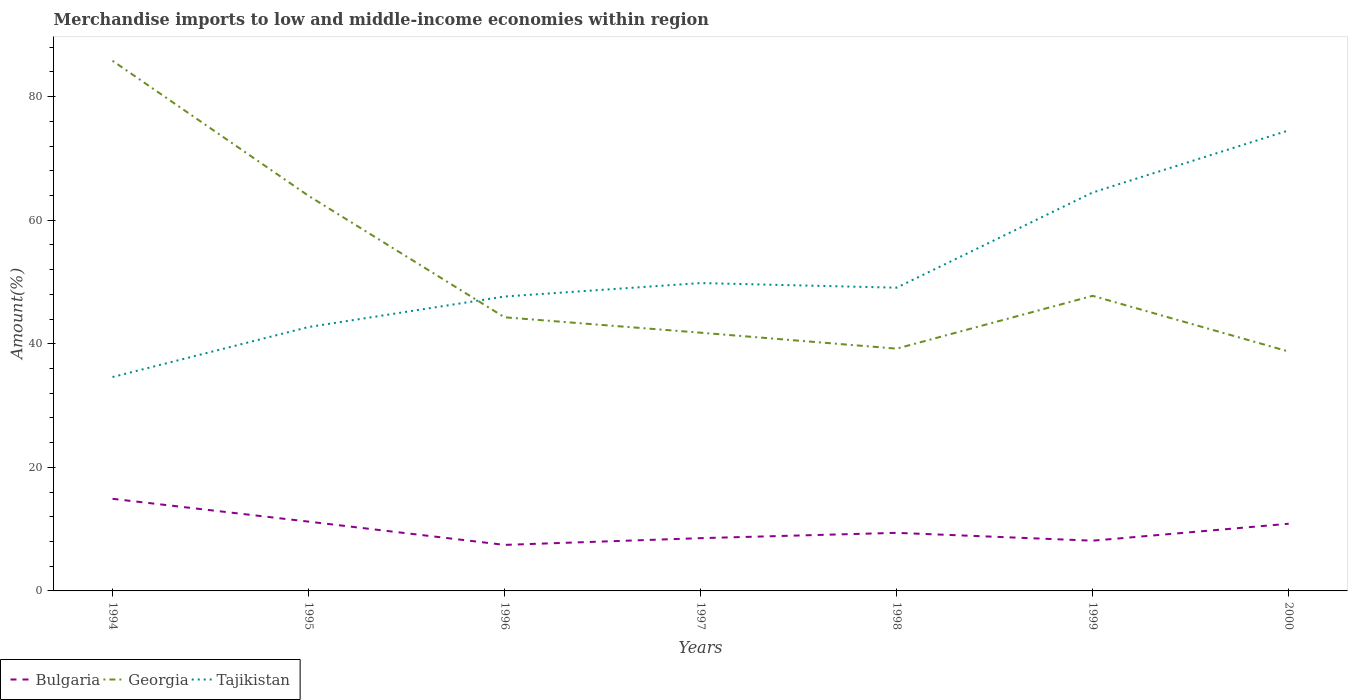How many different coloured lines are there?
Your answer should be compact. 3. Is the number of lines equal to the number of legend labels?
Provide a short and direct response. Yes. Across all years, what is the maximum percentage of amount earned from merchandise imports in Bulgaria?
Keep it short and to the point. 7.45. What is the total percentage of amount earned from merchandise imports in Georgia in the graph?
Provide a succinct answer. 9.01. What is the difference between the highest and the second highest percentage of amount earned from merchandise imports in Tajikistan?
Provide a short and direct response. 39.92. How many years are there in the graph?
Your answer should be very brief. 7. Does the graph contain any zero values?
Provide a short and direct response. No. Does the graph contain grids?
Make the answer very short. No. Where does the legend appear in the graph?
Offer a very short reply. Bottom left. How are the legend labels stacked?
Your answer should be very brief. Horizontal. What is the title of the graph?
Your response must be concise. Merchandise imports to low and middle-income economies within region. What is the label or title of the X-axis?
Give a very brief answer. Years. What is the label or title of the Y-axis?
Ensure brevity in your answer.  Amount(%). What is the Amount(%) of Bulgaria in 1994?
Your answer should be compact. 14.91. What is the Amount(%) of Georgia in 1994?
Ensure brevity in your answer.  85.81. What is the Amount(%) in Tajikistan in 1994?
Make the answer very short. 34.62. What is the Amount(%) in Bulgaria in 1995?
Make the answer very short. 11.22. What is the Amount(%) of Georgia in 1995?
Keep it short and to the point. 63.95. What is the Amount(%) in Tajikistan in 1995?
Provide a succinct answer. 42.71. What is the Amount(%) in Bulgaria in 1996?
Make the answer very short. 7.45. What is the Amount(%) of Georgia in 1996?
Provide a succinct answer. 44.29. What is the Amount(%) of Tajikistan in 1996?
Keep it short and to the point. 47.65. What is the Amount(%) in Bulgaria in 1997?
Your answer should be compact. 8.54. What is the Amount(%) of Georgia in 1997?
Ensure brevity in your answer.  41.8. What is the Amount(%) in Tajikistan in 1997?
Your answer should be compact. 49.83. What is the Amount(%) in Bulgaria in 1998?
Provide a succinct answer. 9.4. What is the Amount(%) of Georgia in 1998?
Ensure brevity in your answer.  39.22. What is the Amount(%) in Tajikistan in 1998?
Ensure brevity in your answer.  49.08. What is the Amount(%) in Bulgaria in 1999?
Offer a very short reply. 8.13. What is the Amount(%) in Georgia in 1999?
Your answer should be compact. 47.76. What is the Amount(%) in Tajikistan in 1999?
Provide a succinct answer. 64.49. What is the Amount(%) of Bulgaria in 2000?
Your answer should be very brief. 10.87. What is the Amount(%) in Georgia in 2000?
Offer a very short reply. 38.75. What is the Amount(%) of Tajikistan in 2000?
Your answer should be compact. 74.54. Across all years, what is the maximum Amount(%) of Bulgaria?
Your answer should be very brief. 14.91. Across all years, what is the maximum Amount(%) of Georgia?
Provide a succinct answer. 85.81. Across all years, what is the maximum Amount(%) of Tajikistan?
Keep it short and to the point. 74.54. Across all years, what is the minimum Amount(%) in Bulgaria?
Offer a terse response. 7.45. Across all years, what is the minimum Amount(%) in Georgia?
Your response must be concise. 38.75. Across all years, what is the minimum Amount(%) in Tajikistan?
Give a very brief answer. 34.62. What is the total Amount(%) of Bulgaria in the graph?
Your answer should be very brief. 70.52. What is the total Amount(%) of Georgia in the graph?
Ensure brevity in your answer.  361.57. What is the total Amount(%) in Tajikistan in the graph?
Offer a terse response. 362.93. What is the difference between the Amount(%) in Bulgaria in 1994 and that in 1995?
Keep it short and to the point. 3.69. What is the difference between the Amount(%) in Georgia in 1994 and that in 1995?
Your answer should be very brief. 21.86. What is the difference between the Amount(%) of Tajikistan in 1994 and that in 1995?
Your answer should be very brief. -8.09. What is the difference between the Amount(%) of Bulgaria in 1994 and that in 1996?
Give a very brief answer. 7.46. What is the difference between the Amount(%) of Georgia in 1994 and that in 1996?
Ensure brevity in your answer.  41.52. What is the difference between the Amount(%) of Tajikistan in 1994 and that in 1996?
Give a very brief answer. -13.03. What is the difference between the Amount(%) in Bulgaria in 1994 and that in 1997?
Give a very brief answer. 6.37. What is the difference between the Amount(%) in Georgia in 1994 and that in 1997?
Your response must be concise. 44.01. What is the difference between the Amount(%) of Tajikistan in 1994 and that in 1997?
Offer a very short reply. -15.21. What is the difference between the Amount(%) in Bulgaria in 1994 and that in 1998?
Your answer should be very brief. 5.51. What is the difference between the Amount(%) of Georgia in 1994 and that in 1998?
Your answer should be very brief. 46.59. What is the difference between the Amount(%) in Tajikistan in 1994 and that in 1998?
Offer a terse response. -14.46. What is the difference between the Amount(%) in Bulgaria in 1994 and that in 1999?
Offer a very short reply. 6.78. What is the difference between the Amount(%) in Georgia in 1994 and that in 1999?
Provide a succinct answer. 38.05. What is the difference between the Amount(%) of Tajikistan in 1994 and that in 1999?
Ensure brevity in your answer.  -29.87. What is the difference between the Amount(%) in Bulgaria in 1994 and that in 2000?
Your answer should be very brief. 4.04. What is the difference between the Amount(%) in Georgia in 1994 and that in 2000?
Your answer should be compact. 47.06. What is the difference between the Amount(%) in Tajikistan in 1994 and that in 2000?
Give a very brief answer. -39.92. What is the difference between the Amount(%) in Bulgaria in 1995 and that in 1996?
Keep it short and to the point. 3.76. What is the difference between the Amount(%) of Georgia in 1995 and that in 1996?
Keep it short and to the point. 19.66. What is the difference between the Amount(%) in Tajikistan in 1995 and that in 1996?
Make the answer very short. -4.94. What is the difference between the Amount(%) of Bulgaria in 1995 and that in 1997?
Offer a very short reply. 2.68. What is the difference between the Amount(%) in Georgia in 1995 and that in 1997?
Provide a short and direct response. 22.15. What is the difference between the Amount(%) of Tajikistan in 1995 and that in 1997?
Give a very brief answer. -7.12. What is the difference between the Amount(%) in Bulgaria in 1995 and that in 1998?
Provide a succinct answer. 1.82. What is the difference between the Amount(%) in Georgia in 1995 and that in 1998?
Make the answer very short. 24.73. What is the difference between the Amount(%) of Tajikistan in 1995 and that in 1998?
Offer a terse response. -6.37. What is the difference between the Amount(%) of Bulgaria in 1995 and that in 1999?
Offer a very short reply. 3.08. What is the difference between the Amount(%) of Georgia in 1995 and that in 1999?
Offer a very short reply. 16.19. What is the difference between the Amount(%) in Tajikistan in 1995 and that in 1999?
Offer a very short reply. -21.78. What is the difference between the Amount(%) in Bulgaria in 1995 and that in 2000?
Your response must be concise. 0.34. What is the difference between the Amount(%) in Georgia in 1995 and that in 2000?
Offer a very short reply. 25.2. What is the difference between the Amount(%) in Tajikistan in 1995 and that in 2000?
Ensure brevity in your answer.  -31.83. What is the difference between the Amount(%) of Bulgaria in 1996 and that in 1997?
Provide a short and direct response. -1.09. What is the difference between the Amount(%) in Georgia in 1996 and that in 1997?
Ensure brevity in your answer.  2.49. What is the difference between the Amount(%) of Tajikistan in 1996 and that in 1997?
Your response must be concise. -2.18. What is the difference between the Amount(%) in Bulgaria in 1996 and that in 1998?
Your answer should be very brief. -1.95. What is the difference between the Amount(%) in Georgia in 1996 and that in 1998?
Provide a short and direct response. 5.07. What is the difference between the Amount(%) in Tajikistan in 1996 and that in 1998?
Offer a terse response. -1.43. What is the difference between the Amount(%) of Bulgaria in 1996 and that in 1999?
Offer a very short reply. -0.68. What is the difference between the Amount(%) of Georgia in 1996 and that in 1999?
Your answer should be very brief. -3.47. What is the difference between the Amount(%) in Tajikistan in 1996 and that in 1999?
Your answer should be very brief. -16.84. What is the difference between the Amount(%) of Bulgaria in 1996 and that in 2000?
Keep it short and to the point. -3.42. What is the difference between the Amount(%) of Georgia in 1996 and that in 2000?
Ensure brevity in your answer.  5.54. What is the difference between the Amount(%) in Tajikistan in 1996 and that in 2000?
Provide a succinct answer. -26.89. What is the difference between the Amount(%) in Bulgaria in 1997 and that in 1998?
Make the answer very short. -0.86. What is the difference between the Amount(%) of Georgia in 1997 and that in 1998?
Your response must be concise. 2.58. What is the difference between the Amount(%) of Tajikistan in 1997 and that in 1998?
Offer a terse response. 0.75. What is the difference between the Amount(%) of Bulgaria in 1997 and that in 1999?
Ensure brevity in your answer.  0.41. What is the difference between the Amount(%) of Georgia in 1997 and that in 1999?
Keep it short and to the point. -5.96. What is the difference between the Amount(%) of Tajikistan in 1997 and that in 1999?
Keep it short and to the point. -14.66. What is the difference between the Amount(%) in Bulgaria in 1997 and that in 2000?
Your response must be concise. -2.33. What is the difference between the Amount(%) of Georgia in 1997 and that in 2000?
Give a very brief answer. 3.05. What is the difference between the Amount(%) in Tajikistan in 1997 and that in 2000?
Provide a succinct answer. -24.71. What is the difference between the Amount(%) in Bulgaria in 1998 and that in 1999?
Keep it short and to the point. 1.27. What is the difference between the Amount(%) in Georgia in 1998 and that in 1999?
Your answer should be compact. -8.55. What is the difference between the Amount(%) of Tajikistan in 1998 and that in 1999?
Offer a terse response. -15.41. What is the difference between the Amount(%) of Bulgaria in 1998 and that in 2000?
Provide a succinct answer. -1.47. What is the difference between the Amount(%) in Georgia in 1998 and that in 2000?
Your answer should be very brief. 0.47. What is the difference between the Amount(%) in Tajikistan in 1998 and that in 2000?
Make the answer very short. -25.46. What is the difference between the Amount(%) of Bulgaria in 1999 and that in 2000?
Keep it short and to the point. -2.74. What is the difference between the Amount(%) of Georgia in 1999 and that in 2000?
Provide a succinct answer. 9.01. What is the difference between the Amount(%) of Tajikistan in 1999 and that in 2000?
Give a very brief answer. -10.05. What is the difference between the Amount(%) in Bulgaria in 1994 and the Amount(%) in Georgia in 1995?
Your answer should be compact. -49.04. What is the difference between the Amount(%) of Bulgaria in 1994 and the Amount(%) of Tajikistan in 1995?
Keep it short and to the point. -27.8. What is the difference between the Amount(%) in Georgia in 1994 and the Amount(%) in Tajikistan in 1995?
Give a very brief answer. 43.09. What is the difference between the Amount(%) of Bulgaria in 1994 and the Amount(%) of Georgia in 1996?
Ensure brevity in your answer.  -29.38. What is the difference between the Amount(%) in Bulgaria in 1994 and the Amount(%) in Tajikistan in 1996?
Your answer should be very brief. -32.74. What is the difference between the Amount(%) in Georgia in 1994 and the Amount(%) in Tajikistan in 1996?
Offer a terse response. 38.16. What is the difference between the Amount(%) in Bulgaria in 1994 and the Amount(%) in Georgia in 1997?
Make the answer very short. -26.89. What is the difference between the Amount(%) in Bulgaria in 1994 and the Amount(%) in Tajikistan in 1997?
Provide a short and direct response. -34.92. What is the difference between the Amount(%) in Georgia in 1994 and the Amount(%) in Tajikistan in 1997?
Your answer should be very brief. 35.98. What is the difference between the Amount(%) of Bulgaria in 1994 and the Amount(%) of Georgia in 1998?
Offer a very short reply. -24.31. What is the difference between the Amount(%) in Bulgaria in 1994 and the Amount(%) in Tajikistan in 1998?
Your response must be concise. -34.17. What is the difference between the Amount(%) of Georgia in 1994 and the Amount(%) of Tajikistan in 1998?
Your response must be concise. 36.73. What is the difference between the Amount(%) in Bulgaria in 1994 and the Amount(%) in Georgia in 1999?
Offer a terse response. -32.85. What is the difference between the Amount(%) in Bulgaria in 1994 and the Amount(%) in Tajikistan in 1999?
Give a very brief answer. -49.58. What is the difference between the Amount(%) of Georgia in 1994 and the Amount(%) of Tajikistan in 1999?
Offer a terse response. 21.32. What is the difference between the Amount(%) of Bulgaria in 1994 and the Amount(%) of Georgia in 2000?
Provide a succinct answer. -23.84. What is the difference between the Amount(%) of Bulgaria in 1994 and the Amount(%) of Tajikistan in 2000?
Your answer should be compact. -59.63. What is the difference between the Amount(%) of Georgia in 1994 and the Amount(%) of Tajikistan in 2000?
Your answer should be very brief. 11.27. What is the difference between the Amount(%) of Bulgaria in 1995 and the Amount(%) of Georgia in 1996?
Your response must be concise. -33.07. What is the difference between the Amount(%) in Bulgaria in 1995 and the Amount(%) in Tajikistan in 1996?
Provide a short and direct response. -36.44. What is the difference between the Amount(%) in Georgia in 1995 and the Amount(%) in Tajikistan in 1996?
Provide a short and direct response. 16.3. What is the difference between the Amount(%) of Bulgaria in 1995 and the Amount(%) of Georgia in 1997?
Provide a succinct answer. -30.58. What is the difference between the Amount(%) of Bulgaria in 1995 and the Amount(%) of Tajikistan in 1997?
Make the answer very short. -38.61. What is the difference between the Amount(%) of Georgia in 1995 and the Amount(%) of Tajikistan in 1997?
Give a very brief answer. 14.12. What is the difference between the Amount(%) in Bulgaria in 1995 and the Amount(%) in Georgia in 1998?
Give a very brief answer. -28. What is the difference between the Amount(%) in Bulgaria in 1995 and the Amount(%) in Tajikistan in 1998?
Your answer should be very brief. -37.87. What is the difference between the Amount(%) in Georgia in 1995 and the Amount(%) in Tajikistan in 1998?
Your response must be concise. 14.87. What is the difference between the Amount(%) in Bulgaria in 1995 and the Amount(%) in Georgia in 1999?
Provide a short and direct response. -36.55. What is the difference between the Amount(%) in Bulgaria in 1995 and the Amount(%) in Tajikistan in 1999?
Ensure brevity in your answer.  -53.27. What is the difference between the Amount(%) of Georgia in 1995 and the Amount(%) of Tajikistan in 1999?
Your response must be concise. -0.54. What is the difference between the Amount(%) in Bulgaria in 1995 and the Amount(%) in Georgia in 2000?
Offer a very short reply. -27.53. What is the difference between the Amount(%) in Bulgaria in 1995 and the Amount(%) in Tajikistan in 2000?
Make the answer very short. -63.33. What is the difference between the Amount(%) in Georgia in 1995 and the Amount(%) in Tajikistan in 2000?
Your answer should be very brief. -10.59. What is the difference between the Amount(%) in Bulgaria in 1996 and the Amount(%) in Georgia in 1997?
Provide a short and direct response. -34.35. What is the difference between the Amount(%) in Bulgaria in 1996 and the Amount(%) in Tajikistan in 1997?
Your answer should be compact. -42.38. What is the difference between the Amount(%) of Georgia in 1996 and the Amount(%) of Tajikistan in 1997?
Ensure brevity in your answer.  -5.54. What is the difference between the Amount(%) of Bulgaria in 1996 and the Amount(%) of Georgia in 1998?
Provide a short and direct response. -31.77. What is the difference between the Amount(%) in Bulgaria in 1996 and the Amount(%) in Tajikistan in 1998?
Offer a terse response. -41.63. What is the difference between the Amount(%) of Georgia in 1996 and the Amount(%) of Tajikistan in 1998?
Your response must be concise. -4.79. What is the difference between the Amount(%) of Bulgaria in 1996 and the Amount(%) of Georgia in 1999?
Ensure brevity in your answer.  -40.31. What is the difference between the Amount(%) in Bulgaria in 1996 and the Amount(%) in Tajikistan in 1999?
Give a very brief answer. -57.04. What is the difference between the Amount(%) in Georgia in 1996 and the Amount(%) in Tajikistan in 1999?
Your answer should be very brief. -20.2. What is the difference between the Amount(%) in Bulgaria in 1996 and the Amount(%) in Georgia in 2000?
Offer a very short reply. -31.3. What is the difference between the Amount(%) of Bulgaria in 1996 and the Amount(%) of Tajikistan in 2000?
Ensure brevity in your answer.  -67.09. What is the difference between the Amount(%) in Georgia in 1996 and the Amount(%) in Tajikistan in 2000?
Your answer should be compact. -30.25. What is the difference between the Amount(%) of Bulgaria in 1997 and the Amount(%) of Georgia in 1998?
Offer a terse response. -30.68. What is the difference between the Amount(%) of Bulgaria in 1997 and the Amount(%) of Tajikistan in 1998?
Your response must be concise. -40.54. What is the difference between the Amount(%) of Georgia in 1997 and the Amount(%) of Tajikistan in 1998?
Ensure brevity in your answer.  -7.29. What is the difference between the Amount(%) in Bulgaria in 1997 and the Amount(%) in Georgia in 1999?
Your response must be concise. -39.22. What is the difference between the Amount(%) in Bulgaria in 1997 and the Amount(%) in Tajikistan in 1999?
Your response must be concise. -55.95. What is the difference between the Amount(%) of Georgia in 1997 and the Amount(%) of Tajikistan in 1999?
Provide a short and direct response. -22.69. What is the difference between the Amount(%) in Bulgaria in 1997 and the Amount(%) in Georgia in 2000?
Provide a short and direct response. -30.21. What is the difference between the Amount(%) in Bulgaria in 1997 and the Amount(%) in Tajikistan in 2000?
Keep it short and to the point. -66. What is the difference between the Amount(%) of Georgia in 1997 and the Amount(%) of Tajikistan in 2000?
Provide a succinct answer. -32.74. What is the difference between the Amount(%) in Bulgaria in 1998 and the Amount(%) in Georgia in 1999?
Your answer should be very brief. -38.36. What is the difference between the Amount(%) in Bulgaria in 1998 and the Amount(%) in Tajikistan in 1999?
Ensure brevity in your answer.  -55.09. What is the difference between the Amount(%) of Georgia in 1998 and the Amount(%) of Tajikistan in 1999?
Offer a terse response. -25.27. What is the difference between the Amount(%) in Bulgaria in 1998 and the Amount(%) in Georgia in 2000?
Your answer should be very brief. -29.35. What is the difference between the Amount(%) in Bulgaria in 1998 and the Amount(%) in Tajikistan in 2000?
Your answer should be very brief. -65.14. What is the difference between the Amount(%) of Georgia in 1998 and the Amount(%) of Tajikistan in 2000?
Ensure brevity in your answer.  -35.33. What is the difference between the Amount(%) in Bulgaria in 1999 and the Amount(%) in Georgia in 2000?
Keep it short and to the point. -30.62. What is the difference between the Amount(%) of Bulgaria in 1999 and the Amount(%) of Tajikistan in 2000?
Ensure brevity in your answer.  -66.41. What is the difference between the Amount(%) of Georgia in 1999 and the Amount(%) of Tajikistan in 2000?
Your answer should be compact. -26.78. What is the average Amount(%) in Bulgaria per year?
Your answer should be very brief. 10.07. What is the average Amount(%) of Georgia per year?
Ensure brevity in your answer.  51.65. What is the average Amount(%) of Tajikistan per year?
Make the answer very short. 51.85. In the year 1994, what is the difference between the Amount(%) of Bulgaria and Amount(%) of Georgia?
Ensure brevity in your answer.  -70.9. In the year 1994, what is the difference between the Amount(%) of Bulgaria and Amount(%) of Tajikistan?
Give a very brief answer. -19.71. In the year 1994, what is the difference between the Amount(%) of Georgia and Amount(%) of Tajikistan?
Your response must be concise. 51.19. In the year 1995, what is the difference between the Amount(%) of Bulgaria and Amount(%) of Georgia?
Make the answer very short. -52.73. In the year 1995, what is the difference between the Amount(%) of Bulgaria and Amount(%) of Tajikistan?
Keep it short and to the point. -31.5. In the year 1995, what is the difference between the Amount(%) in Georgia and Amount(%) in Tajikistan?
Give a very brief answer. 21.24. In the year 1996, what is the difference between the Amount(%) in Bulgaria and Amount(%) in Georgia?
Your answer should be very brief. -36.84. In the year 1996, what is the difference between the Amount(%) of Bulgaria and Amount(%) of Tajikistan?
Keep it short and to the point. -40.2. In the year 1996, what is the difference between the Amount(%) in Georgia and Amount(%) in Tajikistan?
Your answer should be compact. -3.36. In the year 1997, what is the difference between the Amount(%) of Bulgaria and Amount(%) of Georgia?
Offer a terse response. -33.26. In the year 1997, what is the difference between the Amount(%) of Bulgaria and Amount(%) of Tajikistan?
Offer a terse response. -41.29. In the year 1997, what is the difference between the Amount(%) of Georgia and Amount(%) of Tajikistan?
Provide a succinct answer. -8.03. In the year 1998, what is the difference between the Amount(%) in Bulgaria and Amount(%) in Georgia?
Keep it short and to the point. -29.82. In the year 1998, what is the difference between the Amount(%) in Bulgaria and Amount(%) in Tajikistan?
Your answer should be compact. -39.68. In the year 1998, what is the difference between the Amount(%) in Georgia and Amount(%) in Tajikistan?
Keep it short and to the point. -9.87. In the year 1999, what is the difference between the Amount(%) in Bulgaria and Amount(%) in Georgia?
Your answer should be very brief. -39.63. In the year 1999, what is the difference between the Amount(%) of Bulgaria and Amount(%) of Tajikistan?
Your response must be concise. -56.36. In the year 1999, what is the difference between the Amount(%) of Georgia and Amount(%) of Tajikistan?
Give a very brief answer. -16.73. In the year 2000, what is the difference between the Amount(%) in Bulgaria and Amount(%) in Georgia?
Give a very brief answer. -27.88. In the year 2000, what is the difference between the Amount(%) in Bulgaria and Amount(%) in Tajikistan?
Provide a succinct answer. -63.67. In the year 2000, what is the difference between the Amount(%) in Georgia and Amount(%) in Tajikistan?
Give a very brief answer. -35.79. What is the ratio of the Amount(%) in Bulgaria in 1994 to that in 1995?
Ensure brevity in your answer.  1.33. What is the ratio of the Amount(%) in Georgia in 1994 to that in 1995?
Your answer should be very brief. 1.34. What is the ratio of the Amount(%) in Tajikistan in 1994 to that in 1995?
Offer a terse response. 0.81. What is the ratio of the Amount(%) of Bulgaria in 1994 to that in 1996?
Provide a short and direct response. 2. What is the ratio of the Amount(%) in Georgia in 1994 to that in 1996?
Your answer should be compact. 1.94. What is the ratio of the Amount(%) in Tajikistan in 1994 to that in 1996?
Offer a terse response. 0.73. What is the ratio of the Amount(%) in Bulgaria in 1994 to that in 1997?
Make the answer very short. 1.75. What is the ratio of the Amount(%) in Georgia in 1994 to that in 1997?
Ensure brevity in your answer.  2.05. What is the ratio of the Amount(%) in Tajikistan in 1994 to that in 1997?
Make the answer very short. 0.69. What is the ratio of the Amount(%) of Bulgaria in 1994 to that in 1998?
Your answer should be compact. 1.59. What is the ratio of the Amount(%) of Georgia in 1994 to that in 1998?
Keep it short and to the point. 2.19. What is the ratio of the Amount(%) of Tajikistan in 1994 to that in 1998?
Offer a terse response. 0.71. What is the ratio of the Amount(%) in Bulgaria in 1994 to that in 1999?
Provide a succinct answer. 1.83. What is the ratio of the Amount(%) of Georgia in 1994 to that in 1999?
Give a very brief answer. 1.8. What is the ratio of the Amount(%) in Tajikistan in 1994 to that in 1999?
Your response must be concise. 0.54. What is the ratio of the Amount(%) of Bulgaria in 1994 to that in 2000?
Offer a very short reply. 1.37. What is the ratio of the Amount(%) in Georgia in 1994 to that in 2000?
Keep it short and to the point. 2.21. What is the ratio of the Amount(%) in Tajikistan in 1994 to that in 2000?
Your response must be concise. 0.46. What is the ratio of the Amount(%) of Bulgaria in 1995 to that in 1996?
Keep it short and to the point. 1.51. What is the ratio of the Amount(%) in Georgia in 1995 to that in 1996?
Give a very brief answer. 1.44. What is the ratio of the Amount(%) of Tajikistan in 1995 to that in 1996?
Make the answer very short. 0.9. What is the ratio of the Amount(%) in Bulgaria in 1995 to that in 1997?
Give a very brief answer. 1.31. What is the ratio of the Amount(%) in Georgia in 1995 to that in 1997?
Your answer should be very brief. 1.53. What is the ratio of the Amount(%) in Tajikistan in 1995 to that in 1997?
Provide a succinct answer. 0.86. What is the ratio of the Amount(%) of Bulgaria in 1995 to that in 1998?
Give a very brief answer. 1.19. What is the ratio of the Amount(%) in Georgia in 1995 to that in 1998?
Keep it short and to the point. 1.63. What is the ratio of the Amount(%) in Tajikistan in 1995 to that in 1998?
Offer a terse response. 0.87. What is the ratio of the Amount(%) in Bulgaria in 1995 to that in 1999?
Ensure brevity in your answer.  1.38. What is the ratio of the Amount(%) of Georgia in 1995 to that in 1999?
Your response must be concise. 1.34. What is the ratio of the Amount(%) in Tajikistan in 1995 to that in 1999?
Provide a succinct answer. 0.66. What is the ratio of the Amount(%) of Bulgaria in 1995 to that in 2000?
Ensure brevity in your answer.  1.03. What is the ratio of the Amount(%) in Georgia in 1995 to that in 2000?
Offer a very short reply. 1.65. What is the ratio of the Amount(%) in Tajikistan in 1995 to that in 2000?
Your response must be concise. 0.57. What is the ratio of the Amount(%) in Bulgaria in 1996 to that in 1997?
Offer a very short reply. 0.87. What is the ratio of the Amount(%) in Georgia in 1996 to that in 1997?
Make the answer very short. 1.06. What is the ratio of the Amount(%) of Tajikistan in 1996 to that in 1997?
Your answer should be compact. 0.96. What is the ratio of the Amount(%) in Bulgaria in 1996 to that in 1998?
Your response must be concise. 0.79. What is the ratio of the Amount(%) of Georgia in 1996 to that in 1998?
Give a very brief answer. 1.13. What is the ratio of the Amount(%) in Tajikistan in 1996 to that in 1998?
Your response must be concise. 0.97. What is the ratio of the Amount(%) in Bulgaria in 1996 to that in 1999?
Keep it short and to the point. 0.92. What is the ratio of the Amount(%) of Georgia in 1996 to that in 1999?
Offer a very short reply. 0.93. What is the ratio of the Amount(%) of Tajikistan in 1996 to that in 1999?
Offer a terse response. 0.74. What is the ratio of the Amount(%) of Bulgaria in 1996 to that in 2000?
Provide a succinct answer. 0.69. What is the ratio of the Amount(%) of Georgia in 1996 to that in 2000?
Keep it short and to the point. 1.14. What is the ratio of the Amount(%) of Tajikistan in 1996 to that in 2000?
Your response must be concise. 0.64. What is the ratio of the Amount(%) in Bulgaria in 1997 to that in 1998?
Keep it short and to the point. 0.91. What is the ratio of the Amount(%) in Georgia in 1997 to that in 1998?
Keep it short and to the point. 1.07. What is the ratio of the Amount(%) of Tajikistan in 1997 to that in 1998?
Give a very brief answer. 1.02. What is the ratio of the Amount(%) in Bulgaria in 1997 to that in 1999?
Provide a short and direct response. 1.05. What is the ratio of the Amount(%) in Georgia in 1997 to that in 1999?
Your answer should be very brief. 0.88. What is the ratio of the Amount(%) of Tajikistan in 1997 to that in 1999?
Ensure brevity in your answer.  0.77. What is the ratio of the Amount(%) in Bulgaria in 1997 to that in 2000?
Offer a terse response. 0.79. What is the ratio of the Amount(%) of Georgia in 1997 to that in 2000?
Provide a short and direct response. 1.08. What is the ratio of the Amount(%) of Tajikistan in 1997 to that in 2000?
Offer a very short reply. 0.67. What is the ratio of the Amount(%) in Bulgaria in 1998 to that in 1999?
Provide a succinct answer. 1.16. What is the ratio of the Amount(%) of Georgia in 1998 to that in 1999?
Offer a terse response. 0.82. What is the ratio of the Amount(%) of Tajikistan in 1998 to that in 1999?
Keep it short and to the point. 0.76. What is the ratio of the Amount(%) in Bulgaria in 1998 to that in 2000?
Provide a short and direct response. 0.86. What is the ratio of the Amount(%) in Georgia in 1998 to that in 2000?
Provide a succinct answer. 1.01. What is the ratio of the Amount(%) in Tajikistan in 1998 to that in 2000?
Your answer should be compact. 0.66. What is the ratio of the Amount(%) of Bulgaria in 1999 to that in 2000?
Give a very brief answer. 0.75. What is the ratio of the Amount(%) in Georgia in 1999 to that in 2000?
Give a very brief answer. 1.23. What is the ratio of the Amount(%) in Tajikistan in 1999 to that in 2000?
Ensure brevity in your answer.  0.87. What is the difference between the highest and the second highest Amount(%) in Bulgaria?
Your response must be concise. 3.69. What is the difference between the highest and the second highest Amount(%) in Georgia?
Provide a succinct answer. 21.86. What is the difference between the highest and the second highest Amount(%) in Tajikistan?
Provide a short and direct response. 10.05. What is the difference between the highest and the lowest Amount(%) of Bulgaria?
Keep it short and to the point. 7.46. What is the difference between the highest and the lowest Amount(%) in Georgia?
Provide a short and direct response. 47.06. What is the difference between the highest and the lowest Amount(%) in Tajikistan?
Make the answer very short. 39.92. 